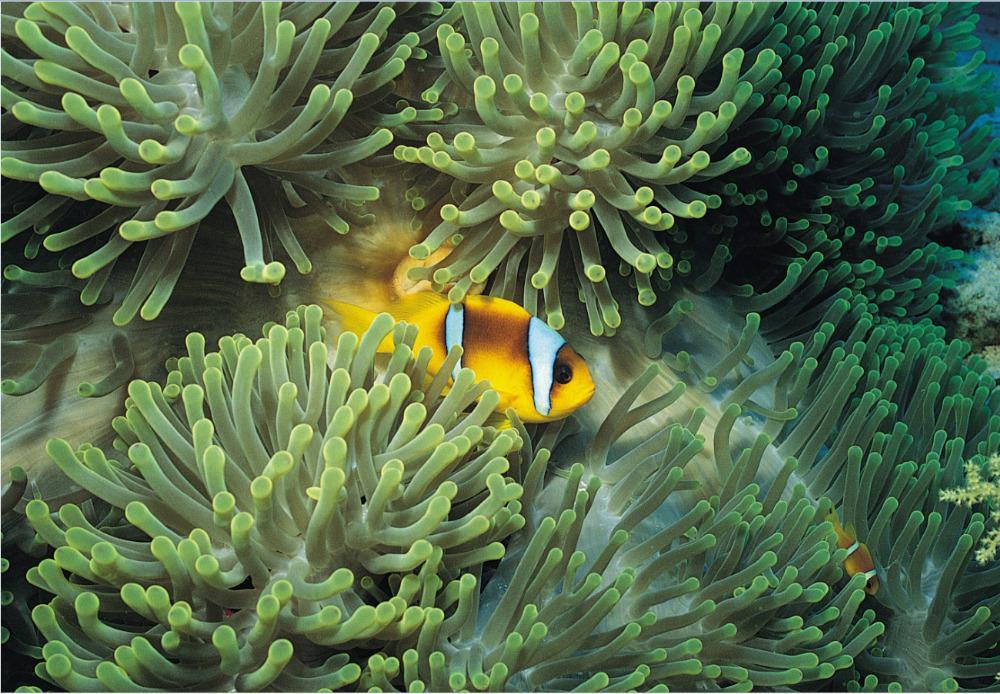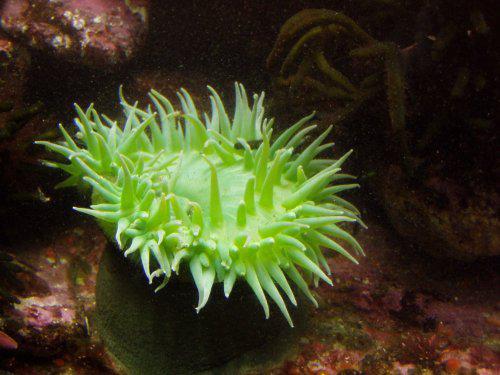The first image is the image on the left, the second image is the image on the right. Examine the images to the left and right. Is the description "Left and right images feature one prominent neon-greenish anemone, and a center spot is visible in at least one anemone." accurate? Answer yes or no. No. The first image is the image on the left, the second image is the image on the right. Analyze the images presented: Is the assertion "There are only two Sea anemones" valid? Answer yes or no. No. 